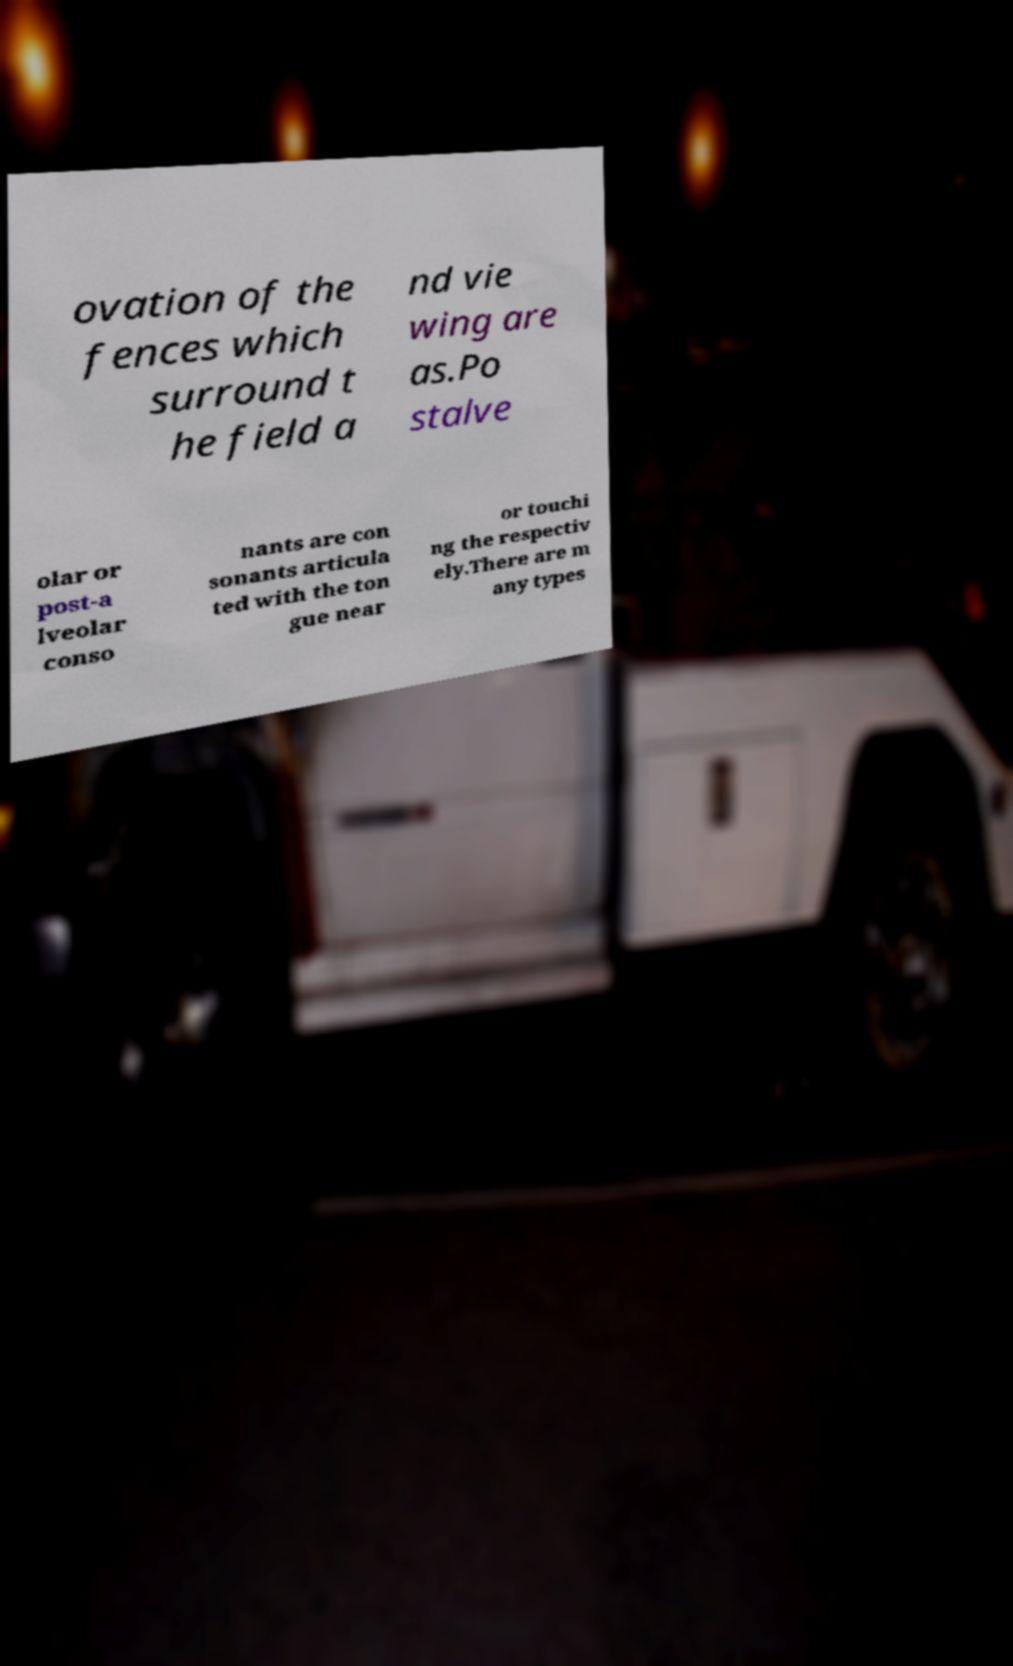What messages or text are displayed in this image? I need them in a readable, typed format. ovation of the fences which surround t he field a nd vie wing are as.Po stalve olar or post-a lveolar conso nants are con sonants articula ted with the ton gue near or touchi ng the respectiv ely.There are m any types 